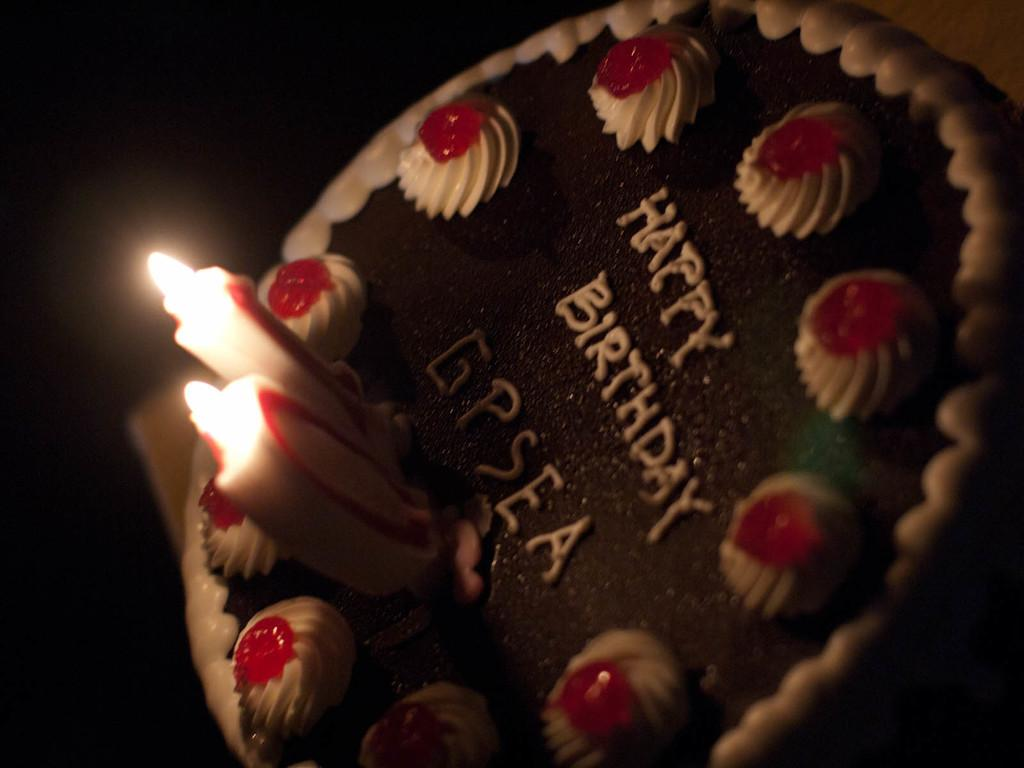What is on top of the cake in the image? There are candles on the cake in the image. How many zebras are standing next to the cake in the image? There are no zebras present in the image. 